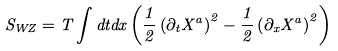Convert formula to latex. <formula><loc_0><loc_0><loc_500><loc_500>S _ { W Z } = T \int d t d x \left ( \frac { 1 } { 2 } \left ( \partial _ { t } X ^ { a } \right ) ^ { 2 } - \frac { 1 } { 2 } \left ( \partial _ { x } X ^ { a } \right ) ^ { 2 } \right )</formula> 